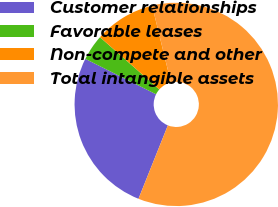Convert chart. <chart><loc_0><loc_0><loc_500><loc_500><pie_chart><fcel>Customer relationships<fcel>Favorable leases<fcel>Non-compete and other<fcel>Total intangible assets<nl><fcel>26.33%<fcel>4.11%<fcel>9.69%<fcel>59.87%<nl></chart> 